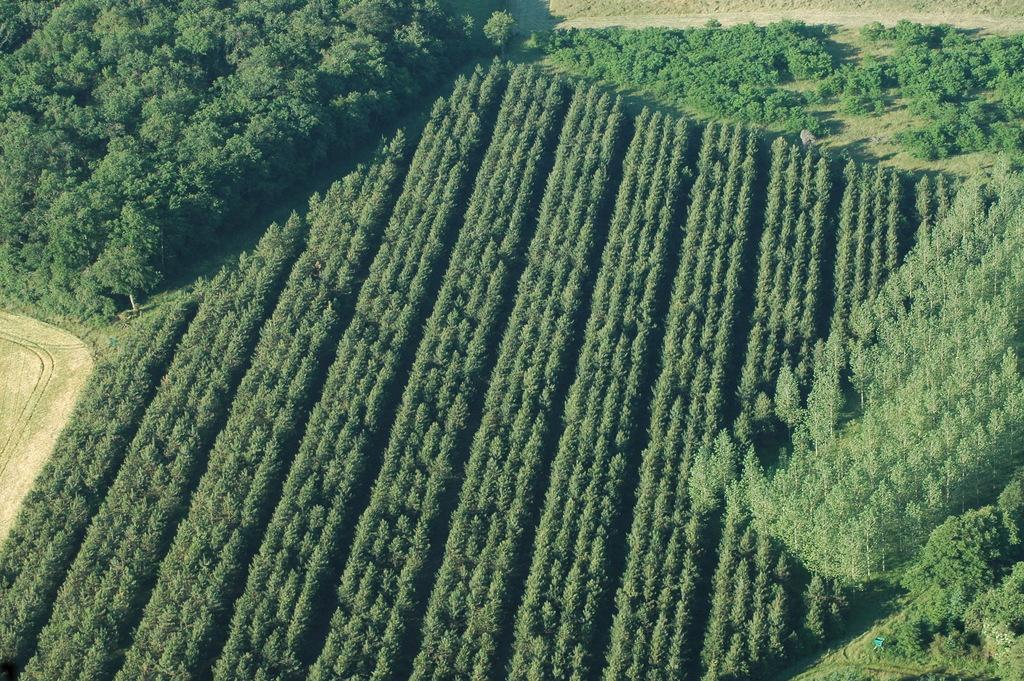Please provide a concise description of this image. In this image the land is covered with trees. 